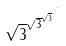Convert formula to latex. <formula><loc_0><loc_0><loc_500><loc_500>\sqrt { 3 } ^ { \sqrt { 3 } ^ { \sqrt { 3 } ^ { \cdot ^ { \cdot ^ { \cdot } } } } }</formula> 